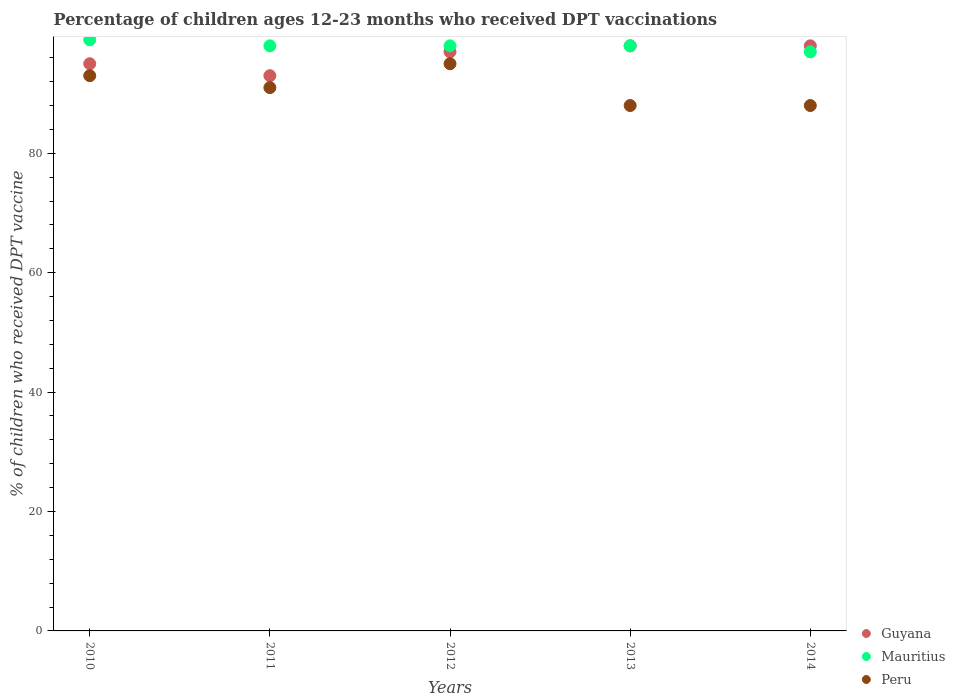How many different coloured dotlines are there?
Give a very brief answer. 3. What is the percentage of children who received DPT vaccination in Guyana in 2012?
Offer a terse response. 97. Across all years, what is the maximum percentage of children who received DPT vaccination in Mauritius?
Give a very brief answer. 99. Across all years, what is the minimum percentage of children who received DPT vaccination in Peru?
Keep it short and to the point. 88. In which year was the percentage of children who received DPT vaccination in Guyana maximum?
Make the answer very short. 2013. In which year was the percentage of children who received DPT vaccination in Mauritius minimum?
Offer a terse response. 2014. What is the total percentage of children who received DPT vaccination in Guyana in the graph?
Provide a short and direct response. 481. What is the difference between the percentage of children who received DPT vaccination in Peru in 2010 and that in 2011?
Your answer should be compact. 2. What is the difference between the percentage of children who received DPT vaccination in Peru in 2010 and the percentage of children who received DPT vaccination in Mauritius in 2012?
Make the answer very short. -5. What is the average percentage of children who received DPT vaccination in Mauritius per year?
Your answer should be very brief. 98. In the year 2012, what is the difference between the percentage of children who received DPT vaccination in Mauritius and percentage of children who received DPT vaccination in Guyana?
Provide a short and direct response. 1. Is the percentage of children who received DPT vaccination in Guyana in 2010 less than that in 2014?
Provide a short and direct response. Yes. Is the difference between the percentage of children who received DPT vaccination in Mauritius in 2011 and 2014 greater than the difference between the percentage of children who received DPT vaccination in Guyana in 2011 and 2014?
Provide a short and direct response. Yes. What is the difference between the highest and the second highest percentage of children who received DPT vaccination in Peru?
Ensure brevity in your answer.  2. What is the difference between the highest and the lowest percentage of children who received DPT vaccination in Peru?
Offer a very short reply. 7. In how many years, is the percentage of children who received DPT vaccination in Guyana greater than the average percentage of children who received DPT vaccination in Guyana taken over all years?
Provide a short and direct response. 3. Is the sum of the percentage of children who received DPT vaccination in Mauritius in 2010 and 2012 greater than the maximum percentage of children who received DPT vaccination in Peru across all years?
Give a very brief answer. Yes. Is it the case that in every year, the sum of the percentage of children who received DPT vaccination in Peru and percentage of children who received DPT vaccination in Guyana  is greater than the percentage of children who received DPT vaccination in Mauritius?
Make the answer very short. Yes. What is the difference between two consecutive major ticks on the Y-axis?
Your response must be concise. 20. Does the graph contain any zero values?
Your response must be concise. No. What is the title of the graph?
Offer a very short reply. Percentage of children ages 12-23 months who received DPT vaccinations. Does "Hong Kong" appear as one of the legend labels in the graph?
Keep it short and to the point. No. What is the label or title of the Y-axis?
Ensure brevity in your answer.  % of children who received DPT vaccine. What is the % of children who received DPT vaccine in Guyana in 2010?
Make the answer very short. 95. What is the % of children who received DPT vaccine in Mauritius in 2010?
Offer a very short reply. 99. What is the % of children who received DPT vaccine of Peru in 2010?
Your answer should be compact. 93. What is the % of children who received DPT vaccine of Guyana in 2011?
Your response must be concise. 93. What is the % of children who received DPT vaccine of Mauritius in 2011?
Your response must be concise. 98. What is the % of children who received DPT vaccine in Peru in 2011?
Your answer should be compact. 91. What is the % of children who received DPT vaccine of Guyana in 2012?
Offer a very short reply. 97. What is the % of children who received DPT vaccine of Mauritius in 2012?
Make the answer very short. 98. What is the % of children who received DPT vaccine of Peru in 2012?
Give a very brief answer. 95. What is the % of children who received DPT vaccine of Mauritius in 2013?
Ensure brevity in your answer.  98. What is the % of children who received DPT vaccine of Guyana in 2014?
Your answer should be very brief. 98. What is the % of children who received DPT vaccine of Mauritius in 2014?
Your response must be concise. 97. What is the % of children who received DPT vaccine in Peru in 2014?
Your answer should be very brief. 88. Across all years, what is the maximum % of children who received DPT vaccine in Guyana?
Your answer should be very brief. 98. Across all years, what is the maximum % of children who received DPT vaccine of Peru?
Give a very brief answer. 95. Across all years, what is the minimum % of children who received DPT vaccine of Guyana?
Keep it short and to the point. 93. Across all years, what is the minimum % of children who received DPT vaccine of Mauritius?
Your answer should be very brief. 97. What is the total % of children who received DPT vaccine of Guyana in the graph?
Provide a short and direct response. 481. What is the total % of children who received DPT vaccine of Mauritius in the graph?
Ensure brevity in your answer.  490. What is the total % of children who received DPT vaccine of Peru in the graph?
Your answer should be compact. 455. What is the difference between the % of children who received DPT vaccine in Guyana in 2010 and that in 2011?
Make the answer very short. 2. What is the difference between the % of children who received DPT vaccine in Peru in 2010 and that in 2011?
Your answer should be very brief. 2. What is the difference between the % of children who received DPT vaccine in Peru in 2010 and that in 2013?
Provide a short and direct response. 5. What is the difference between the % of children who received DPT vaccine of Guyana in 2010 and that in 2014?
Your answer should be very brief. -3. What is the difference between the % of children who received DPT vaccine of Peru in 2010 and that in 2014?
Keep it short and to the point. 5. What is the difference between the % of children who received DPT vaccine of Mauritius in 2011 and that in 2012?
Offer a terse response. 0. What is the difference between the % of children who received DPT vaccine of Peru in 2011 and that in 2012?
Offer a very short reply. -4. What is the difference between the % of children who received DPT vaccine in Mauritius in 2012 and that in 2013?
Offer a very short reply. 0. What is the difference between the % of children who received DPT vaccine of Peru in 2012 and that in 2013?
Your answer should be compact. 7. What is the difference between the % of children who received DPT vaccine in Guyana in 2012 and that in 2014?
Your response must be concise. -1. What is the difference between the % of children who received DPT vaccine in Peru in 2012 and that in 2014?
Provide a succinct answer. 7. What is the difference between the % of children who received DPT vaccine in Guyana in 2013 and that in 2014?
Make the answer very short. 0. What is the difference between the % of children who received DPT vaccine of Mauritius in 2013 and that in 2014?
Your answer should be very brief. 1. What is the difference between the % of children who received DPT vaccine in Guyana in 2010 and the % of children who received DPT vaccine in Mauritius in 2011?
Your answer should be compact. -3. What is the difference between the % of children who received DPT vaccine in Guyana in 2010 and the % of children who received DPT vaccine in Peru in 2012?
Your answer should be very brief. 0. What is the difference between the % of children who received DPT vaccine of Mauritius in 2010 and the % of children who received DPT vaccine of Peru in 2012?
Offer a terse response. 4. What is the difference between the % of children who received DPT vaccine in Guyana in 2010 and the % of children who received DPT vaccine in Mauritius in 2013?
Your answer should be very brief. -3. What is the difference between the % of children who received DPT vaccine of Guyana in 2010 and the % of children who received DPT vaccine of Mauritius in 2014?
Your answer should be compact. -2. What is the difference between the % of children who received DPT vaccine of Guyana in 2011 and the % of children who received DPT vaccine of Mauritius in 2012?
Your answer should be compact. -5. What is the difference between the % of children who received DPT vaccine of Guyana in 2011 and the % of children who received DPT vaccine of Peru in 2012?
Provide a succinct answer. -2. What is the difference between the % of children who received DPT vaccine in Guyana in 2011 and the % of children who received DPT vaccine in Mauritius in 2014?
Give a very brief answer. -4. What is the difference between the % of children who received DPT vaccine of Guyana in 2012 and the % of children who received DPT vaccine of Mauritius in 2013?
Make the answer very short. -1. What is the difference between the % of children who received DPT vaccine of Mauritius in 2012 and the % of children who received DPT vaccine of Peru in 2013?
Ensure brevity in your answer.  10. What is the difference between the % of children who received DPT vaccine of Guyana in 2012 and the % of children who received DPT vaccine of Peru in 2014?
Offer a terse response. 9. What is the difference between the % of children who received DPT vaccine of Mauritius in 2012 and the % of children who received DPT vaccine of Peru in 2014?
Keep it short and to the point. 10. What is the difference between the % of children who received DPT vaccine in Mauritius in 2013 and the % of children who received DPT vaccine in Peru in 2014?
Ensure brevity in your answer.  10. What is the average % of children who received DPT vaccine in Guyana per year?
Offer a terse response. 96.2. What is the average % of children who received DPT vaccine in Peru per year?
Keep it short and to the point. 91. In the year 2010, what is the difference between the % of children who received DPT vaccine of Guyana and % of children who received DPT vaccine of Mauritius?
Keep it short and to the point. -4. In the year 2010, what is the difference between the % of children who received DPT vaccine of Mauritius and % of children who received DPT vaccine of Peru?
Give a very brief answer. 6. In the year 2011, what is the difference between the % of children who received DPT vaccine of Guyana and % of children who received DPT vaccine of Peru?
Offer a very short reply. 2. In the year 2011, what is the difference between the % of children who received DPT vaccine of Mauritius and % of children who received DPT vaccine of Peru?
Keep it short and to the point. 7. In the year 2012, what is the difference between the % of children who received DPT vaccine in Guyana and % of children who received DPT vaccine in Peru?
Keep it short and to the point. 2. In the year 2012, what is the difference between the % of children who received DPT vaccine of Mauritius and % of children who received DPT vaccine of Peru?
Offer a very short reply. 3. In the year 2013, what is the difference between the % of children who received DPT vaccine of Guyana and % of children who received DPT vaccine of Peru?
Ensure brevity in your answer.  10. In the year 2013, what is the difference between the % of children who received DPT vaccine in Mauritius and % of children who received DPT vaccine in Peru?
Your response must be concise. 10. In the year 2014, what is the difference between the % of children who received DPT vaccine in Guyana and % of children who received DPT vaccine in Mauritius?
Provide a succinct answer. 1. In the year 2014, what is the difference between the % of children who received DPT vaccine of Mauritius and % of children who received DPT vaccine of Peru?
Provide a short and direct response. 9. What is the ratio of the % of children who received DPT vaccine of Guyana in 2010 to that in 2011?
Your answer should be very brief. 1.02. What is the ratio of the % of children who received DPT vaccine of Mauritius in 2010 to that in 2011?
Make the answer very short. 1.01. What is the ratio of the % of children who received DPT vaccine of Peru in 2010 to that in 2011?
Provide a short and direct response. 1.02. What is the ratio of the % of children who received DPT vaccine in Guyana in 2010 to that in 2012?
Provide a succinct answer. 0.98. What is the ratio of the % of children who received DPT vaccine in Mauritius in 2010 to that in 2012?
Offer a very short reply. 1.01. What is the ratio of the % of children who received DPT vaccine in Peru in 2010 to that in 2012?
Make the answer very short. 0.98. What is the ratio of the % of children who received DPT vaccine in Guyana in 2010 to that in 2013?
Give a very brief answer. 0.97. What is the ratio of the % of children who received DPT vaccine of Mauritius in 2010 to that in 2013?
Your answer should be very brief. 1.01. What is the ratio of the % of children who received DPT vaccine in Peru in 2010 to that in 2013?
Offer a very short reply. 1.06. What is the ratio of the % of children who received DPT vaccine in Guyana in 2010 to that in 2014?
Make the answer very short. 0.97. What is the ratio of the % of children who received DPT vaccine of Mauritius in 2010 to that in 2014?
Your response must be concise. 1.02. What is the ratio of the % of children who received DPT vaccine of Peru in 2010 to that in 2014?
Ensure brevity in your answer.  1.06. What is the ratio of the % of children who received DPT vaccine of Guyana in 2011 to that in 2012?
Keep it short and to the point. 0.96. What is the ratio of the % of children who received DPT vaccine of Peru in 2011 to that in 2012?
Your answer should be very brief. 0.96. What is the ratio of the % of children who received DPT vaccine of Guyana in 2011 to that in 2013?
Ensure brevity in your answer.  0.95. What is the ratio of the % of children who received DPT vaccine in Peru in 2011 to that in 2013?
Provide a succinct answer. 1.03. What is the ratio of the % of children who received DPT vaccine of Guyana in 2011 to that in 2014?
Keep it short and to the point. 0.95. What is the ratio of the % of children who received DPT vaccine of Mauritius in 2011 to that in 2014?
Your answer should be very brief. 1.01. What is the ratio of the % of children who received DPT vaccine of Peru in 2011 to that in 2014?
Provide a short and direct response. 1.03. What is the ratio of the % of children who received DPT vaccine of Guyana in 2012 to that in 2013?
Keep it short and to the point. 0.99. What is the ratio of the % of children who received DPT vaccine in Mauritius in 2012 to that in 2013?
Provide a short and direct response. 1. What is the ratio of the % of children who received DPT vaccine of Peru in 2012 to that in 2013?
Your answer should be very brief. 1.08. What is the ratio of the % of children who received DPT vaccine in Mauritius in 2012 to that in 2014?
Give a very brief answer. 1.01. What is the ratio of the % of children who received DPT vaccine in Peru in 2012 to that in 2014?
Provide a succinct answer. 1.08. What is the ratio of the % of children who received DPT vaccine of Guyana in 2013 to that in 2014?
Keep it short and to the point. 1. What is the ratio of the % of children who received DPT vaccine in Mauritius in 2013 to that in 2014?
Offer a terse response. 1.01. What is the ratio of the % of children who received DPT vaccine in Peru in 2013 to that in 2014?
Your answer should be compact. 1. What is the difference between the highest and the second highest % of children who received DPT vaccine of Guyana?
Your answer should be compact. 0. What is the difference between the highest and the second highest % of children who received DPT vaccine in Mauritius?
Make the answer very short. 1. What is the difference between the highest and the second highest % of children who received DPT vaccine in Peru?
Your answer should be very brief. 2. What is the difference between the highest and the lowest % of children who received DPT vaccine of Mauritius?
Your answer should be compact. 2. What is the difference between the highest and the lowest % of children who received DPT vaccine of Peru?
Offer a very short reply. 7. 